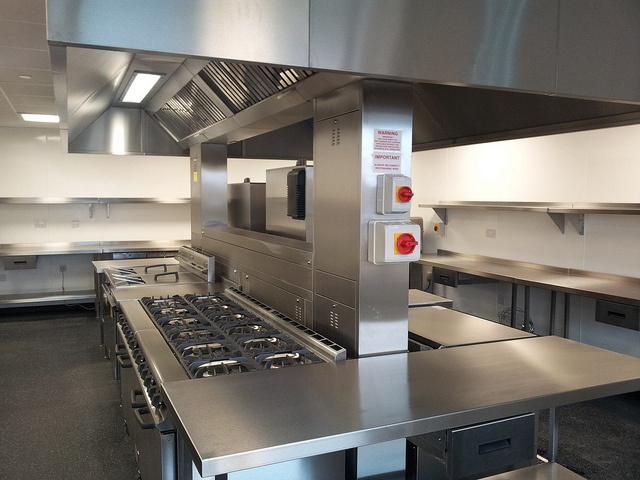Describe the objects in this image and their specific colors. I can see a oven in gray and black tones in this image. 